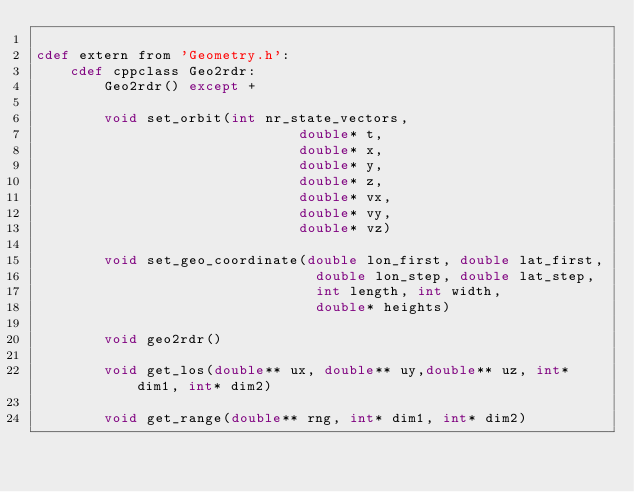Convert code to text. <code><loc_0><loc_0><loc_500><loc_500><_Cython_>
cdef extern from 'Geometry.h':
    cdef cppclass Geo2rdr:
        Geo2rdr() except +

        void set_orbit(int nr_state_vectors,
                               double* t,
                               double* x,
                               double* y,
                               double* z,
                               double* vx,
                               double* vy,
                               double* vz)
 
        void set_geo_coordinate(double lon_first, double lat_first,
                                 double lon_step, double lat_step,
                                 int length, int width,
                                 double* heights)
       
        void geo2rdr()

        void get_los(double** ux, double** uy,double** uz, int* dim1, int* dim2)

        void get_range(double** rng, int* dim1, int* dim2)


</code> 